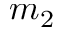Convert formula to latex. <formula><loc_0><loc_0><loc_500><loc_500>m _ { 2 }</formula> 